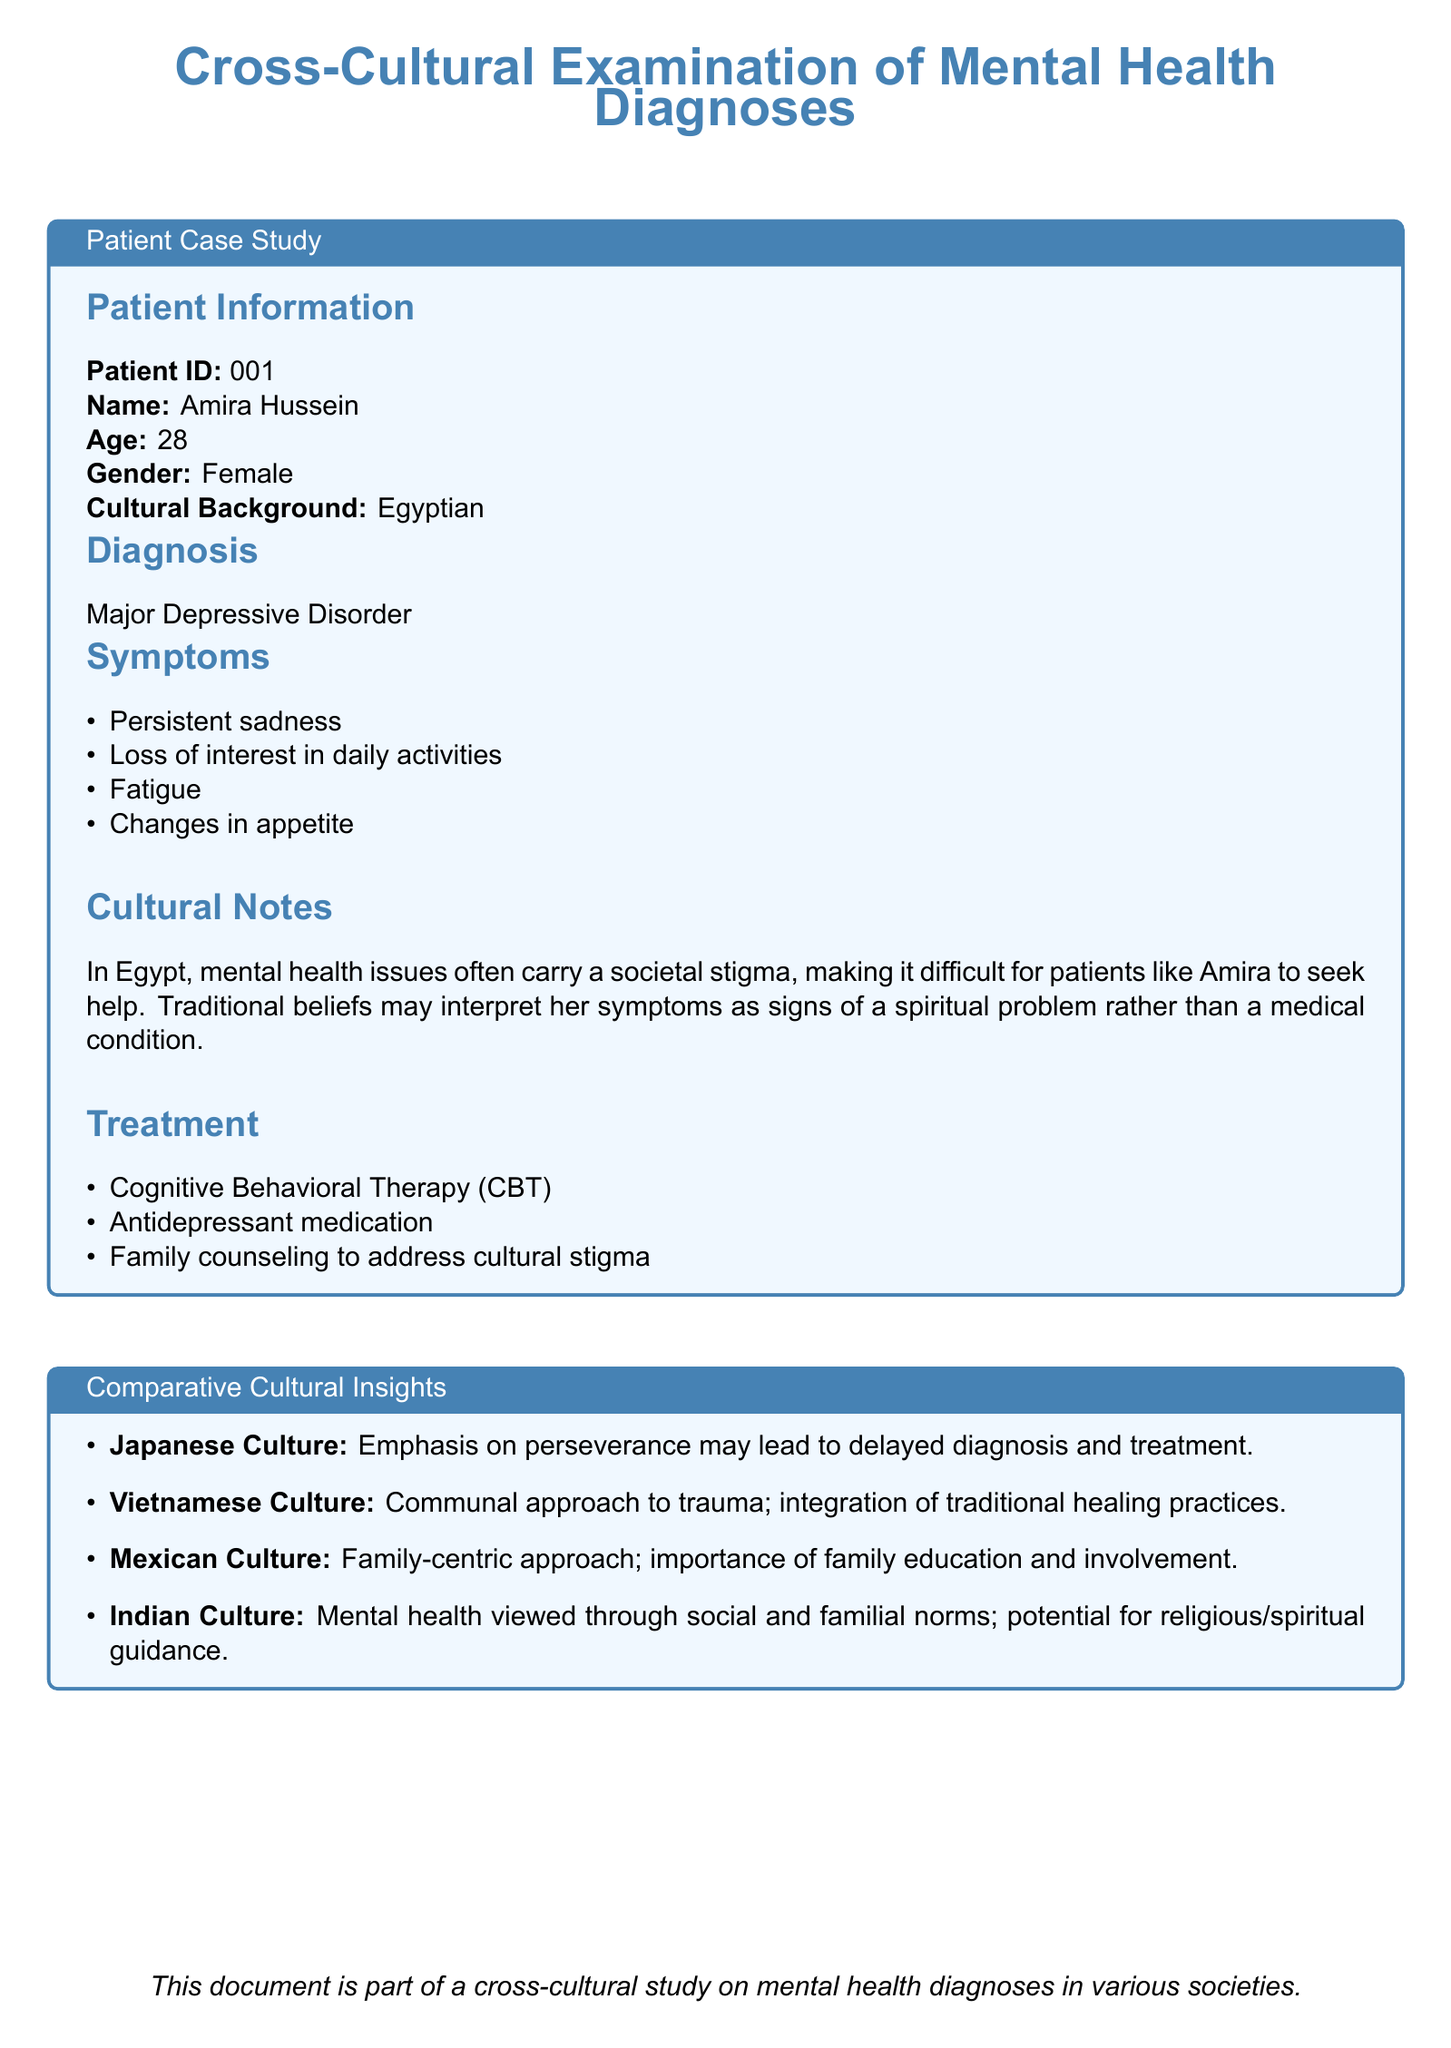What is the patient ID? The patient ID is mentioned in the patient information section of the document as a unique identifier for the case study.
Answer: 001 What is Amira Hussein's age? The document specifies the age of the patient, Amira Hussein, in the patient information section.
Answer: 28 What is the diagnosis for the patient? The diagnosis of Major Depressive Disorder is listed in the diagnosis section of the document.
Answer: Major Depressive Disorder What are two symptoms mentioned in the case study? The symptoms are enumerated in a list format under the symptoms section; any two can be selected.
Answer: Persistent sadness, Loss of interest in daily activities What cultural background does the patient belong to? The cultural background of the patient is detailed in the patient information section.
Answer: Egyptian What treatment method is included for addressing cultural stigma? The treatment section outlines specific approaches taken to support the patient, including addressing social aspects.
Answer: Family counseling to address cultural stigma Which culture emphasizes perseverance possibly delaying diagnosis? The comparative cultural insights section mentions cultures with different approaches to mental health diagnosis and treatment; one is specifically highlighted.
Answer: Japanese Culture How is trauma approached in Vietnamese culture according to the document? Insight into the Vietnamese culture's perspective on trauma is provided in the comparative cultural insights section.
Answer: Communal approach to trauma; integration of traditional healing practices What major issue is associated with mental health in Egyptian society as noted in the document? The document discusses cultural notes regarding societal perspectives on mental health in Egypt that affect seeking help.
Answer: Societal stigma 